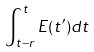Convert formula to latex. <formula><loc_0><loc_0><loc_500><loc_500>\int _ { t - r } ^ { t } E ( t ^ { \prime } ) d t</formula> 